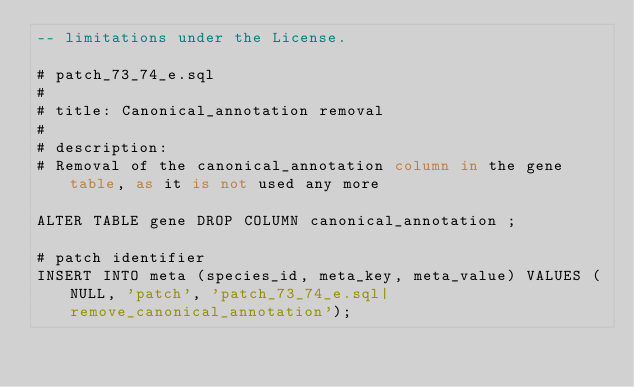<code> <loc_0><loc_0><loc_500><loc_500><_SQL_>-- limitations under the License.

# patch_73_74_e.sql
#
# title: Canonical_annotation removal
#
# description:
# Removal of the canonical_annotation column in the gene table, as it is not used any more

ALTER TABLE gene DROP COLUMN canonical_annotation ;

# patch identifier
INSERT INTO meta (species_id, meta_key, meta_value) VALUES (NULL, 'patch', 'patch_73_74_e.sql|remove_canonical_annotation');

 
</code> 